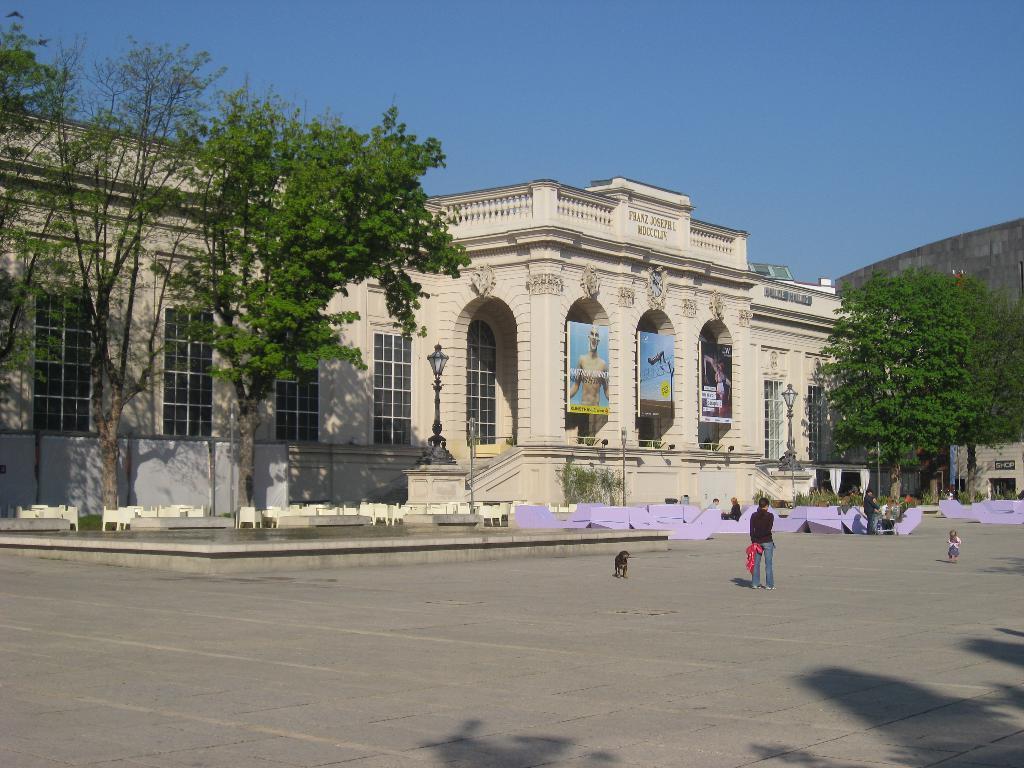How would you summarize this image in a sentence or two? In this image I see the buildings and I see number of trees and I see the light poles and I see few people and I see a dog over here and I see 3 posters over here and I see the path. In the background I see the clear sky. 